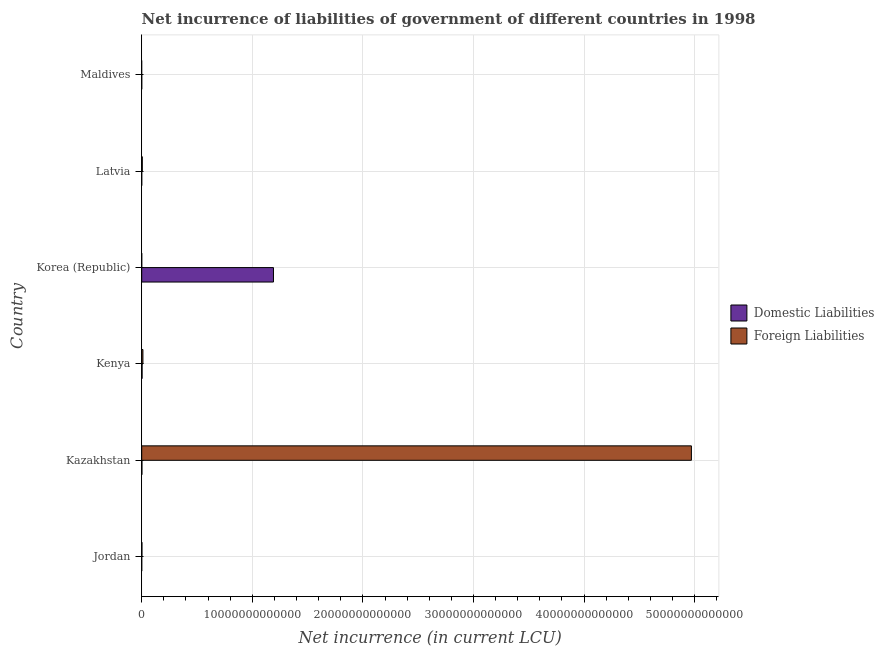How many different coloured bars are there?
Provide a succinct answer. 2. Are the number of bars per tick equal to the number of legend labels?
Provide a short and direct response. No. Are the number of bars on each tick of the Y-axis equal?
Keep it short and to the point. No. How many bars are there on the 2nd tick from the top?
Provide a short and direct response. 1. What is the net incurrence of domestic liabilities in Jordan?
Give a very brief answer. 1.93e+08. Across all countries, what is the maximum net incurrence of foreign liabilities?
Give a very brief answer. 4.97e+13. In which country was the net incurrence of foreign liabilities maximum?
Make the answer very short. Kazakhstan. What is the total net incurrence of foreign liabilities in the graph?
Give a very brief answer. 4.99e+13. What is the difference between the net incurrence of foreign liabilities in Jordan and that in Latvia?
Offer a very short reply. -3.24e+1. What is the difference between the net incurrence of domestic liabilities in Kenya and the net incurrence of foreign liabilities in Korea (Republic)?
Offer a terse response. 3.29e+1. What is the average net incurrence of domestic liabilities per country?
Make the answer very short. 1.99e+12. What is the difference between the net incurrence of foreign liabilities and net incurrence of domestic liabilities in Kazakhstan?
Keep it short and to the point. 4.97e+13. In how many countries, is the net incurrence of domestic liabilities greater than 38000000000000 LCU?
Your answer should be compact. 0. What is the ratio of the net incurrence of foreign liabilities in Jordan to that in Kenya?
Make the answer very short. 0.18. Is the net incurrence of foreign liabilities in Jordan less than that in Kazakhstan?
Ensure brevity in your answer.  Yes. What is the difference between the highest and the second highest net incurrence of domestic liabilities?
Your answer should be very brief. 1.19e+13. What is the difference between the highest and the lowest net incurrence of domestic liabilities?
Make the answer very short. 1.19e+13. What is the difference between two consecutive major ticks on the X-axis?
Give a very brief answer. 1.00e+13. Are the values on the major ticks of X-axis written in scientific E-notation?
Ensure brevity in your answer.  No. Does the graph contain any zero values?
Provide a short and direct response. Yes. How many legend labels are there?
Keep it short and to the point. 2. What is the title of the graph?
Offer a terse response. Net incurrence of liabilities of government of different countries in 1998. Does "Health Care" appear as one of the legend labels in the graph?
Offer a very short reply. No. What is the label or title of the X-axis?
Make the answer very short. Net incurrence (in current LCU). What is the Net incurrence (in current LCU) in Domestic Liabilities in Jordan?
Ensure brevity in your answer.  1.93e+08. What is the Net incurrence (in current LCU) of Foreign Liabilities in Jordan?
Your answer should be compact. 1.92e+1. What is the Net incurrence (in current LCU) in Domestic Liabilities in Kazakhstan?
Your response must be concise. 1.80e+1. What is the Net incurrence (in current LCU) in Foreign Liabilities in Kazakhstan?
Give a very brief answer. 4.97e+13. What is the Net incurrence (in current LCU) in Domestic Liabilities in Kenya?
Offer a terse response. 3.29e+1. What is the Net incurrence (in current LCU) of Foreign Liabilities in Kenya?
Keep it short and to the point. 1.08e+11. What is the Net incurrence (in current LCU) of Domestic Liabilities in Korea (Republic)?
Your answer should be very brief. 1.19e+13. What is the Net incurrence (in current LCU) of Domestic Liabilities in Latvia?
Offer a very short reply. 0. What is the Net incurrence (in current LCU) in Foreign Liabilities in Latvia?
Keep it short and to the point. 5.16e+1. What is the Net incurrence (in current LCU) of Domestic Liabilities in Maldives?
Your answer should be compact. 2.15e+07. Across all countries, what is the maximum Net incurrence (in current LCU) in Domestic Liabilities?
Offer a very short reply. 1.19e+13. Across all countries, what is the maximum Net incurrence (in current LCU) in Foreign Liabilities?
Your response must be concise. 4.97e+13. What is the total Net incurrence (in current LCU) in Domestic Liabilities in the graph?
Give a very brief answer. 1.20e+13. What is the total Net incurrence (in current LCU) in Foreign Liabilities in the graph?
Offer a very short reply. 4.99e+13. What is the difference between the Net incurrence (in current LCU) of Domestic Liabilities in Jordan and that in Kazakhstan?
Ensure brevity in your answer.  -1.78e+1. What is the difference between the Net incurrence (in current LCU) of Foreign Liabilities in Jordan and that in Kazakhstan?
Offer a terse response. -4.97e+13. What is the difference between the Net incurrence (in current LCU) of Domestic Liabilities in Jordan and that in Kenya?
Make the answer very short. -3.27e+1. What is the difference between the Net incurrence (in current LCU) of Foreign Liabilities in Jordan and that in Kenya?
Offer a terse response. -8.88e+1. What is the difference between the Net incurrence (in current LCU) in Domestic Liabilities in Jordan and that in Korea (Republic)?
Your answer should be very brief. -1.19e+13. What is the difference between the Net incurrence (in current LCU) in Foreign Liabilities in Jordan and that in Latvia?
Provide a short and direct response. -3.24e+1. What is the difference between the Net incurrence (in current LCU) of Domestic Liabilities in Jordan and that in Maldives?
Offer a very short reply. 1.71e+08. What is the difference between the Net incurrence (in current LCU) of Domestic Liabilities in Kazakhstan and that in Kenya?
Provide a succinct answer. -1.49e+1. What is the difference between the Net incurrence (in current LCU) of Foreign Liabilities in Kazakhstan and that in Kenya?
Keep it short and to the point. 4.96e+13. What is the difference between the Net incurrence (in current LCU) of Domestic Liabilities in Kazakhstan and that in Korea (Republic)?
Your answer should be very brief. -1.19e+13. What is the difference between the Net incurrence (in current LCU) in Foreign Liabilities in Kazakhstan and that in Latvia?
Keep it short and to the point. 4.97e+13. What is the difference between the Net incurrence (in current LCU) of Domestic Liabilities in Kazakhstan and that in Maldives?
Your answer should be compact. 1.80e+1. What is the difference between the Net incurrence (in current LCU) of Domestic Liabilities in Kenya and that in Korea (Republic)?
Your answer should be very brief. -1.19e+13. What is the difference between the Net incurrence (in current LCU) of Foreign Liabilities in Kenya and that in Latvia?
Offer a very short reply. 5.64e+1. What is the difference between the Net incurrence (in current LCU) in Domestic Liabilities in Kenya and that in Maldives?
Your answer should be very brief. 3.29e+1. What is the difference between the Net incurrence (in current LCU) of Domestic Liabilities in Korea (Republic) and that in Maldives?
Your answer should be very brief. 1.19e+13. What is the difference between the Net incurrence (in current LCU) of Domestic Liabilities in Jordan and the Net incurrence (in current LCU) of Foreign Liabilities in Kazakhstan?
Give a very brief answer. -4.97e+13. What is the difference between the Net incurrence (in current LCU) in Domestic Liabilities in Jordan and the Net incurrence (in current LCU) in Foreign Liabilities in Kenya?
Ensure brevity in your answer.  -1.08e+11. What is the difference between the Net incurrence (in current LCU) in Domestic Liabilities in Jordan and the Net incurrence (in current LCU) in Foreign Liabilities in Latvia?
Offer a terse response. -5.14e+1. What is the difference between the Net incurrence (in current LCU) of Domestic Liabilities in Kazakhstan and the Net incurrence (in current LCU) of Foreign Liabilities in Kenya?
Offer a terse response. -9.00e+1. What is the difference between the Net incurrence (in current LCU) of Domestic Liabilities in Kazakhstan and the Net incurrence (in current LCU) of Foreign Liabilities in Latvia?
Offer a very short reply. -3.36e+1. What is the difference between the Net incurrence (in current LCU) in Domestic Liabilities in Kenya and the Net incurrence (in current LCU) in Foreign Liabilities in Latvia?
Provide a short and direct response. -1.86e+1. What is the difference between the Net incurrence (in current LCU) in Domestic Liabilities in Korea (Republic) and the Net incurrence (in current LCU) in Foreign Liabilities in Latvia?
Your answer should be very brief. 1.19e+13. What is the average Net incurrence (in current LCU) in Domestic Liabilities per country?
Your answer should be compact. 1.99e+12. What is the average Net incurrence (in current LCU) of Foreign Liabilities per country?
Your response must be concise. 8.31e+12. What is the difference between the Net incurrence (in current LCU) of Domestic Liabilities and Net incurrence (in current LCU) of Foreign Liabilities in Jordan?
Your answer should be very brief. -1.90e+1. What is the difference between the Net incurrence (in current LCU) in Domestic Liabilities and Net incurrence (in current LCU) in Foreign Liabilities in Kazakhstan?
Offer a terse response. -4.97e+13. What is the difference between the Net incurrence (in current LCU) in Domestic Liabilities and Net incurrence (in current LCU) in Foreign Liabilities in Kenya?
Keep it short and to the point. -7.51e+1. What is the ratio of the Net incurrence (in current LCU) in Domestic Liabilities in Jordan to that in Kazakhstan?
Your answer should be very brief. 0.01. What is the ratio of the Net incurrence (in current LCU) in Foreign Liabilities in Jordan to that in Kazakhstan?
Make the answer very short. 0. What is the ratio of the Net incurrence (in current LCU) of Domestic Liabilities in Jordan to that in Kenya?
Keep it short and to the point. 0.01. What is the ratio of the Net incurrence (in current LCU) of Foreign Liabilities in Jordan to that in Kenya?
Offer a terse response. 0.18. What is the ratio of the Net incurrence (in current LCU) of Domestic Liabilities in Jordan to that in Korea (Republic)?
Make the answer very short. 0. What is the ratio of the Net incurrence (in current LCU) of Foreign Liabilities in Jordan to that in Latvia?
Your answer should be very brief. 0.37. What is the ratio of the Net incurrence (in current LCU) of Domestic Liabilities in Jordan to that in Maldives?
Make the answer very short. 8.96. What is the ratio of the Net incurrence (in current LCU) of Domestic Liabilities in Kazakhstan to that in Kenya?
Make the answer very short. 0.55. What is the ratio of the Net incurrence (in current LCU) in Foreign Liabilities in Kazakhstan to that in Kenya?
Offer a terse response. 460.23. What is the ratio of the Net incurrence (in current LCU) in Domestic Liabilities in Kazakhstan to that in Korea (Republic)?
Offer a very short reply. 0. What is the ratio of the Net incurrence (in current LCU) of Foreign Liabilities in Kazakhstan to that in Latvia?
Your answer should be compact. 963.86. What is the ratio of the Net incurrence (in current LCU) in Domestic Liabilities in Kazakhstan to that in Maldives?
Provide a succinct answer. 836.93. What is the ratio of the Net incurrence (in current LCU) in Domestic Liabilities in Kenya to that in Korea (Republic)?
Provide a succinct answer. 0. What is the ratio of the Net incurrence (in current LCU) of Foreign Liabilities in Kenya to that in Latvia?
Provide a succinct answer. 2.09. What is the ratio of the Net incurrence (in current LCU) of Domestic Liabilities in Kenya to that in Maldives?
Offer a very short reply. 1532. What is the ratio of the Net incurrence (in current LCU) of Domestic Liabilities in Korea (Republic) to that in Maldives?
Ensure brevity in your answer.  5.54e+05. What is the difference between the highest and the second highest Net incurrence (in current LCU) of Domestic Liabilities?
Your answer should be compact. 1.19e+13. What is the difference between the highest and the second highest Net incurrence (in current LCU) in Foreign Liabilities?
Offer a terse response. 4.96e+13. What is the difference between the highest and the lowest Net incurrence (in current LCU) in Domestic Liabilities?
Your answer should be compact. 1.19e+13. What is the difference between the highest and the lowest Net incurrence (in current LCU) of Foreign Liabilities?
Provide a succinct answer. 4.97e+13. 